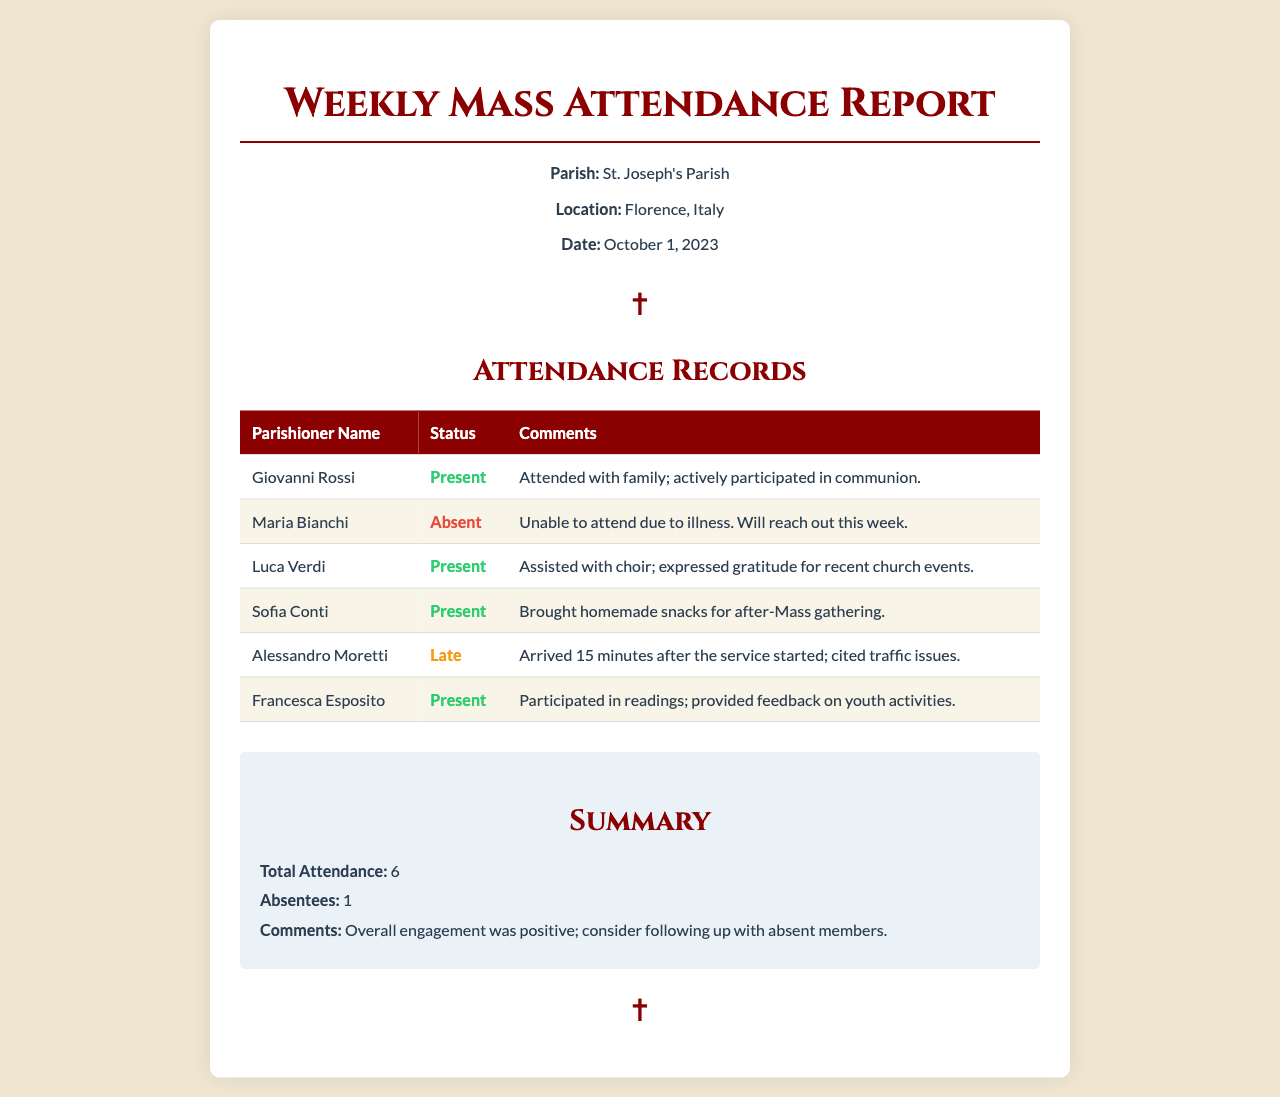What is the name of the parish? The name of the parish is mentioned in the title and parish info section of the document.
Answer: St. Joseph's Parish What is the location of the parish? The location is indicated in the parish info section of the document.
Answer: Florence, Italy What is the date of the report? The date is provided in the parish info section.
Answer: October 1, 2023 How many parishioners are present? This information can be found in the attendance records table; it counts the number of 'Present' statuses.
Answer: 5 Who assisted with the choir? The attendance records table indicates which parishioner took on this role.
Answer: Luca Verdi What was the comment for Maria Bianchi? Comments for each parishioner are listed next to their names in the table.
Answer: Unable to attend due to illness. Will reach out this week How many absentees were reported? This total is summarized in the summary section of the document.
Answer: 1 What issue did Alessandro Moretti cite for arriving late? The reason for Alessandro Moretti's tardiness appears in his status comment.
Answer: Traffic issues What was the total attendance reported? This number is found in the summary section, reflecting the overall attendance.
Answer: 6 What feedback did Francesca Esposito provide? The details on Francesca Esposito's feedback are given in her comments section.
Answer: Provided feedback on youth activities 